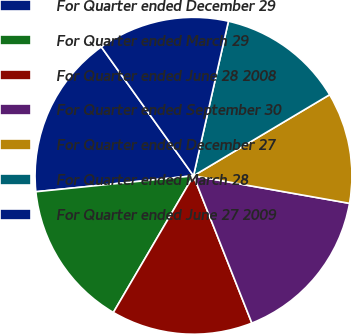Convert chart to OTSL. <chart><loc_0><loc_0><loc_500><loc_500><pie_chart><fcel>For Quarter ended December 29<fcel>For Quarter ended March 29<fcel>For Quarter ended June 28 2008<fcel>For Quarter ended September 30<fcel>For Quarter ended December 27<fcel>For Quarter ended March 28<fcel>For Quarter ended June 27 2009<nl><fcel>16.72%<fcel>14.95%<fcel>14.44%<fcel>16.21%<fcel>11.33%<fcel>12.91%<fcel>13.42%<nl></chart> 